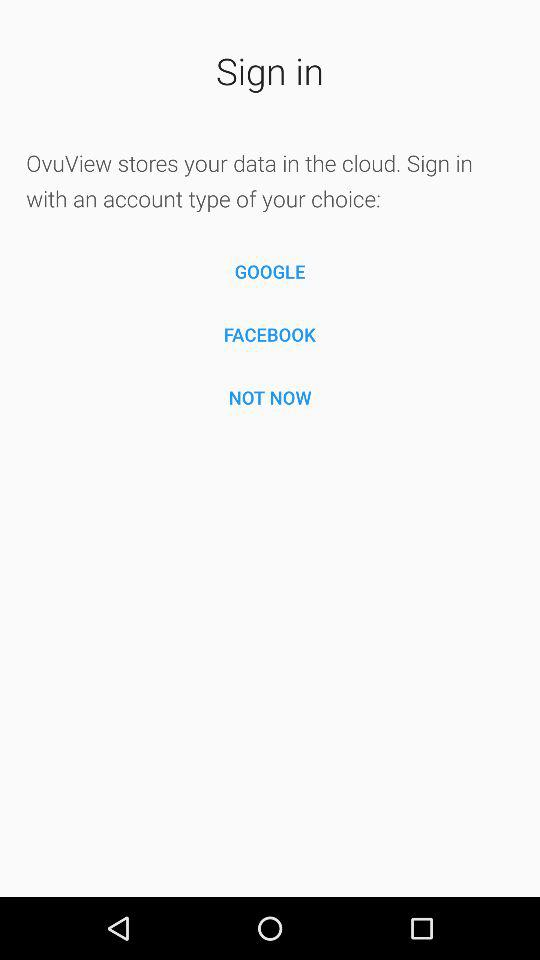What are the different options through which we can sign in? You can sign in through "GOOGLE" and "FACEBOOK". 